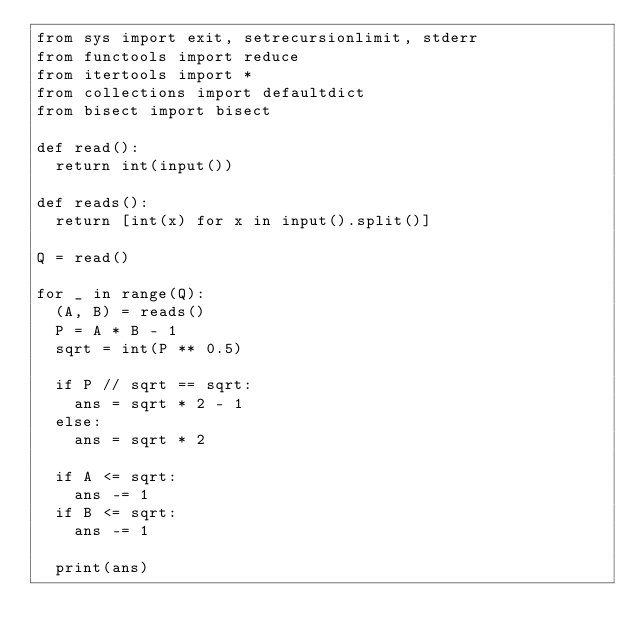<code> <loc_0><loc_0><loc_500><loc_500><_Python_>from sys import exit, setrecursionlimit, stderr
from functools import reduce
from itertools import *
from collections import defaultdict
from bisect import bisect

def read():
  return int(input())

def reads():
  return [int(x) for x in input().split()]

Q = read()

for _ in range(Q):
  (A, B) = reads()
  P = A * B - 1
  sqrt = int(P ** 0.5)
  
  if P // sqrt == sqrt:
    ans = sqrt * 2 - 1
  else:
    ans = sqrt * 2

  if A <= sqrt:
    ans -= 1
  if B <= sqrt:
    ans -= 1

  print(ans)  </code> 